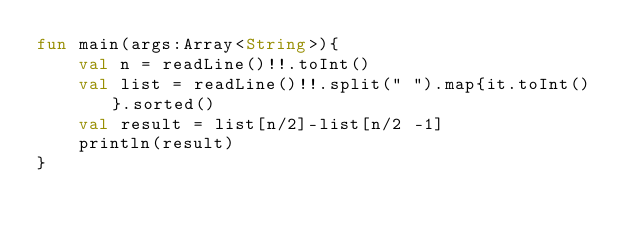Convert code to text. <code><loc_0><loc_0><loc_500><loc_500><_Kotlin_>fun main(args:Array<String>){
    val n = readLine()!!.toInt()
    val list = readLine()!!.split(" ").map{it.toInt()}.sorted()
    val result = list[n/2]-list[n/2 -1]
    println(result)
}</code> 